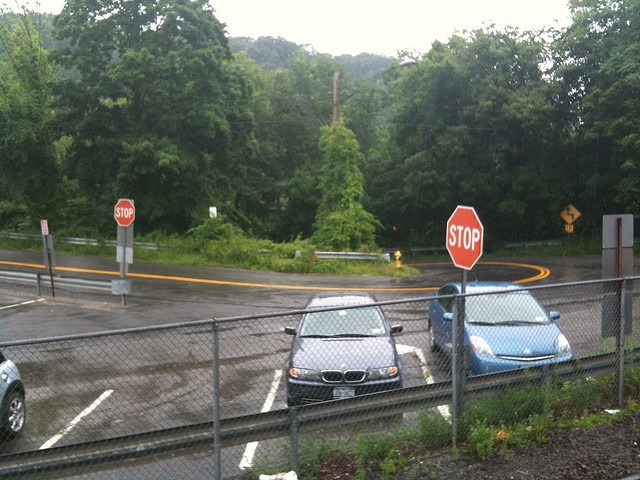Describe the objects in this image and their specific colors. I can see car in white, lavender, darkgray, black, and gray tones, car in white, lightgray, lightblue, gray, and darkgray tones, stop sign in white, salmon, lightpink, and red tones, car in white, black, gray, darkgray, and lightgray tones, and stop sign in white, salmon, lightpink, red, and brown tones in this image. 